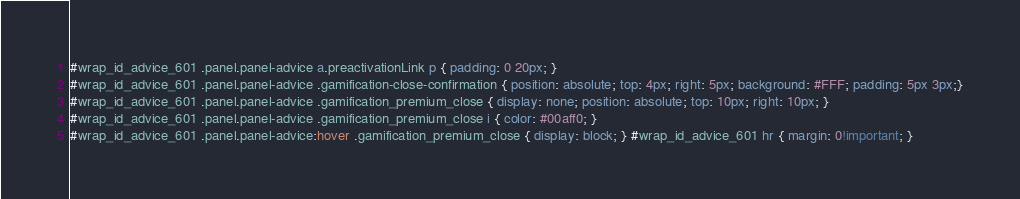Convert code to text. <code><loc_0><loc_0><loc_500><loc_500><_CSS_>#wrap_id_advice_601 .panel.panel-advice a.preactivationLink p { padding: 0 20px; }
#wrap_id_advice_601 .panel.panel-advice .gamification-close-confirmation { position: absolute; top: 4px; right: 5px; background: #FFF; padding: 5px 3px;}
#wrap_id_advice_601 .panel.panel-advice .gamification_premium_close { display: none; position: absolute; top: 10px; right: 10px; }
#wrap_id_advice_601 .panel.panel-advice .gamification_premium_close i { color: #00aff0; }
#wrap_id_advice_601 .panel.panel-advice:hover .gamification_premium_close { display: block; } #wrap_id_advice_601 hr { margin: 0!important; }</code> 